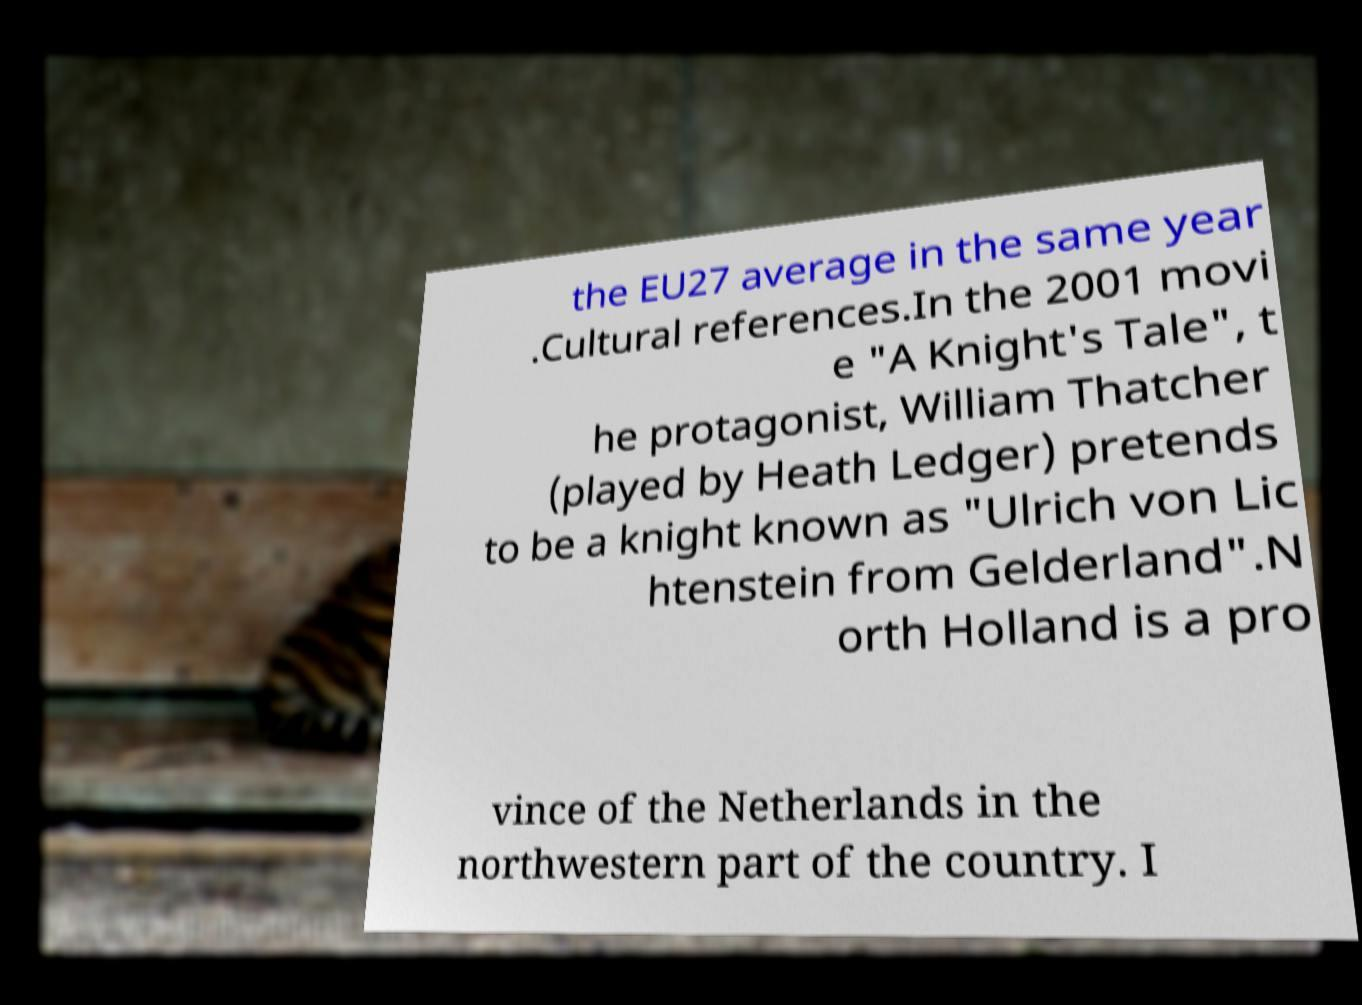Could you assist in decoding the text presented in this image and type it out clearly? the EU27 average in the same year .Cultural references.In the 2001 movi e "A Knight's Tale", t he protagonist, William Thatcher (played by Heath Ledger) pretends to be a knight known as "Ulrich von Lic htenstein from Gelderland".N orth Holland is a pro vince of the Netherlands in the northwestern part of the country. I 